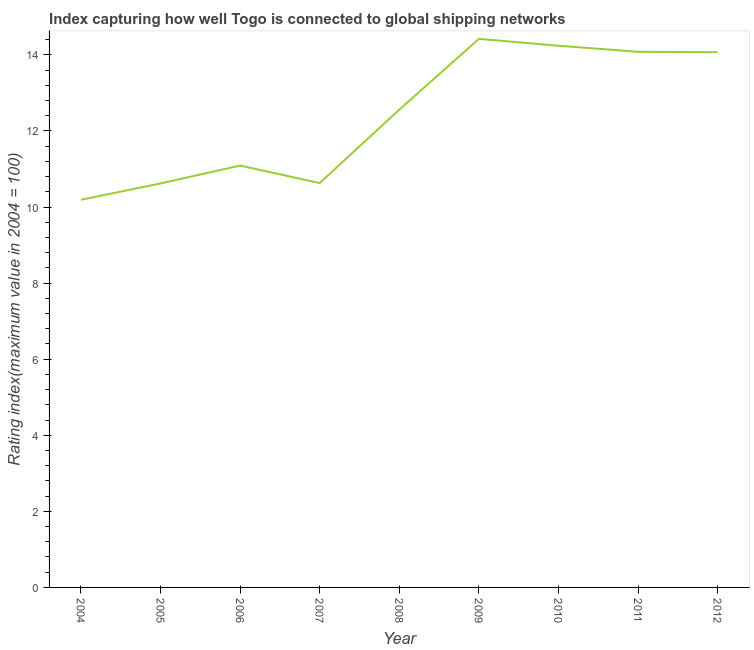What is the liner shipping connectivity index in 2011?
Your response must be concise. 14.08. Across all years, what is the maximum liner shipping connectivity index?
Make the answer very short. 14.42. Across all years, what is the minimum liner shipping connectivity index?
Offer a terse response. 10.19. In which year was the liner shipping connectivity index maximum?
Offer a very short reply. 2009. In which year was the liner shipping connectivity index minimum?
Your answer should be compact. 2004. What is the sum of the liner shipping connectivity index?
Make the answer very short. 111.9. What is the difference between the liner shipping connectivity index in 2004 and 2011?
Your answer should be compact. -3.89. What is the average liner shipping connectivity index per year?
Give a very brief answer. 12.43. What is the median liner shipping connectivity index?
Offer a terse response. 12.56. In how many years, is the liner shipping connectivity index greater than 4 ?
Provide a succinct answer. 9. What is the ratio of the liner shipping connectivity index in 2005 to that in 2011?
Keep it short and to the point. 0.75. Is the difference between the liner shipping connectivity index in 2008 and 2010 greater than the difference between any two years?
Your answer should be compact. No. What is the difference between the highest and the second highest liner shipping connectivity index?
Ensure brevity in your answer.  0.18. What is the difference between the highest and the lowest liner shipping connectivity index?
Provide a succinct answer. 4.23. How many years are there in the graph?
Your answer should be compact. 9. Does the graph contain any zero values?
Keep it short and to the point. No. What is the title of the graph?
Give a very brief answer. Index capturing how well Togo is connected to global shipping networks. What is the label or title of the Y-axis?
Your answer should be very brief. Rating index(maximum value in 2004 = 100). What is the Rating index(maximum value in 2004 = 100) of 2004?
Make the answer very short. 10.19. What is the Rating index(maximum value in 2004 = 100) of 2005?
Provide a short and direct response. 10.62. What is the Rating index(maximum value in 2004 = 100) in 2006?
Ensure brevity in your answer.  11.09. What is the Rating index(maximum value in 2004 = 100) in 2007?
Offer a terse response. 10.63. What is the Rating index(maximum value in 2004 = 100) in 2008?
Your answer should be very brief. 12.56. What is the Rating index(maximum value in 2004 = 100) of 2009?
Ensure brevity in your answer.  14.42. What is the Rating index(maximum value in 2004 = 100) in 2010?
Keep it short and to the point. 14.24. What is the Rating index(maximum value in 2004 = 100) in 2011?
Provide a short and direct response. 14.08. What is the Rating index(maximum value in 2004 = 100) in 2012?
Keep it short and to the point. 14.07. What is the difference between the Rating index(maximum value in 2004 = 100) in 2004 and 2005?
Offer a terse response. -0.43. What is the difference between the Rating index(maximum value in 2004 = 100) in 2004 and 2006?
Make the answer very short. -0.9. What is the difference between the Rating index(maximum value in 2004 = 100) in 2004 and 2007?
Provide a succinct answer. -0.44. What is the difference between the Rating index(maximum value in 2004 = 100) in 2004 and 2008?
Your answer should be compact. -2.37. What is the difference between the Rating index(maximum value in 2004 = 100) in 2004 and 2009?
Keep it short and to the point. -4.23. What is the difference between the Rating index(maximum value in 2004 = 100) in 2004 and 2010?
Offer a very short reply. -4.05. What is the difference between the Rating index(maximum value in 2004 = 100) in 2004 and 2011?
Provide a short and direct response. -3.89. What is the difference between the Rating index(maximum value in 2004 = 100) in 2004 and 2012?
Provide a short and direct response. -3.88. What is the difference between the Rating index(maximum value in 2004 = 100) in 2005 and 2006?
Your response must be concise. -0.47. What is the difference between the Rating index(maximum value in 2004 = 100) in 2005 and 2007?
Provide a short and direct response. -0.01. What is the difference between the Rating index(maximum value in 2004 = 100) in 2005 and 2008?
Ensure brevity in your answer.  -1.94. What is the difference between the Rating index(maximum value in 2004 = 100) in 2005 and 2009?
Your answer should be very brief. -3.8. What is the difference between the Rating index(maximum value in 2004 = 100) in 2005 and 2010?
Your response must be concise. -3.62. What is the difference between the Rating index(maximum value in 2004 = 100) in 2005 and 2011?
Make the answer very short. -3.46. What is the difference between the Rating index(maximum value in 2004 = 100) in 2005 and 2012?
Your answer should be very brief. -3.45. What is the difference between the Rating index(maximum value in 2004 = 100) in 2006 and 2007?
Make the answer very short. 0.46. What is the difference between the Rating index(maximum value in 2004 = 100) in 2006 and 2008?
Keep it short and to the point. -1.47. What is the difference between the Rating index(maximum value in 2004 = 100) in 2006 and 2009?
Offer a terse response. -3.33. What is the difference between the Rating index(maximum value in 2004 = 100) in 2006 and 2010?
Provide a short and direct response. -3.15. What is the difference between the Rating index(maximum value in 2004 = 100) in 2006 and 2011?
Provide a short and direct response. -2.99. What is the difference between the Rating index(maximum value in 2004 = 100) in 2006 and 2012?
Ensure brevity in your answer.  -2.98. What is the difference between the Rating index(maximum value in 2004 = 100) in 2007 and 2008?
Your answer should be compact. -1.93. What is the difference between the Rating index(maximum value in 2004 = 100) in 2007 and 2009?
Your response must be concise. -3.79. What is the difference between the Rating index(maximum value in 2004 = 100) in 2007 and 2010?
Your answer should be very brief. -3.61. What is the difference between the Rating index(maximum value in 2004 = 100) in 2007 and 2011?
Offer a terse response. -3.45. What is the difference between the Rating index(maximum value in 2004 = 100) in 2007 and 2012?
Make the answer very short. -3.44. What is the difference between the Rating index(maximum value in 2004 = 100) in 2008 and 2009?
Make the answer very short. -1.86. What is the difference between the Rating index(maximum value in 2004 = 100) in 2008 and 2010?
Offer a very short reply. -1.68. What is the difference between the Rating index(maximum value in 2004 = 100) in 2008 and 2011?
Your response must be concise. -1.52. What is the difference between the Rating index(maximum value in 2004 = 100) in 2008 and 2012?
Offer a terse response. -1.51. What is the difference between the Rating index(maximum value in 2004 = 100) in 2009 and 2010?
Make the answer very short. 0.18. What is the difference between the Rating index(maximum value in 2004 = 100) in 2009 and 2011?
Your response must be concise. 0.34. What is the difference between the Rating index(maximum value in 2004 = 100) in 2009 and 2012?
Give a very brief answer. 0.35. What is the difference between the Rating index(maximum value in 2004 = 100) in 2010 and 2011?
Keep it short and to the point. 0.16. What is the difference between the Rating index(maximum value in 2004 = 100) in 2010 and 2012?
Make the answer very short. 0.17. What is the difference between the Rating index(maximum value in 2004 = 100) in 2011 and 2012?
Your response must be concise. 0.01. What is the ratio of the Rating index(maximum value in 2004 = 100) in 2004 to that in 2005?
Ensure brevity in your answer.  0.96. What is the ratio of the Rating index(maximum value in 2004 = 100) in 2004 to that in 2006?
Your answer should be compact. 0.92. What is the ratio of the Rating index(maximum value in 2004 = 100) in 2004 to that in 2008?
Give a very brief answer. 0.81. What is the ratio of the Rating index(maximum value in 2004 = 100) in 2004 to that in 2009?
Give a very brief answer. 0.71. What is the ratio of the Rating index(maximum value in 2004 = 100) in 2004 to that in 2010?
Keep it short and to the point. 0.72. What is the ratio of the Rating index(maximum value in 2004 = 100) in 2004 to that in 2011?
Your answer should be very brief. 0.72. What is the ratio of the Rating index(maximum value in 2004 = 100) in 2004 to that in 2012?
Your answer should be compact. 0.72. What is the ratio of the Rating index(maximum value in 2004 = 100) in 2005 to that in 2006?
Offer a very short reply. 0.96. What is the ratio of the Rating index(maximum value in 2004 = 100) in 2005 to that in 2007?
Keep it short and to the point. 1. What is the ratio of the Rating index(maximum value in 2004 = 100) in 2005 to that in 2008?
Provide a short and direct response. 0.85. What is the ratio of the Rating index(maximum value in 2004 = 100) in 2005 to that in 2009?
Your answer should be compact. 0.74. What is the ratio of the Rating index(maximum value in 2004 = 100) in 2005 to that in 2010?
Offer a terse response. 0.75. What is the ratio of the Rating index(maximum value in 2004 = 100) in 2005 to that in 2011?
Your answer should be very brief. 0.75. What is the ratio of the Rating index(maximum value in 2004 = 100) in 2005 to that in 2012?
Provide a short and direct response. 0.76. What is the ratio of the Rating index(maximum value in 2004 = 100) in 2006 to that in 2007?
Ensure brevity in your answer.  1.04. What is the ratio of the Rating index(maximum value in 2004 = 100) in 2006 to that in 2008?
Your answer should be compact. 0.88. What is the ratio of the Rating index(maximum value in 2004 = 100) in 2006 to that in 2009?
Offer a terse response. 0.77. What is the ratio of the Rating index(maximum value in 2004 = 100) in 2006 to that in 2010?
Give a very brief answer. 0.78. What is the ratio of the Rating index(maximum value in 2004 = 100) in 2006 to that in 2011?
Your response must be concise. 0.79. What is the ratio of the Rating index(maximum value in 2004 = 100) in 2006 to that in 2012?
Your answer should be very brief. 0.79. What is the ratio of the Rating index(maximum value in 2004 = 100) in 2007 to that in 2008?
Give a very brief answer. 0.85. What is the ratio of the Rating index(maximum value in 2004 = 100) in 2007 to that in 2009?
Your response must be concise. 0.74. What is the ratio of the Rating index(maximum value in 2004 = 100) in 2007 to that in 2010?
Offer a terse response. 0.75. What is the ratio of the Rating index(maximum value in 2004 = 100) in 2007 to that in 2011?
Keep it short and to the point. 0.76. What is the ratio of the Rating index(maximum value in 2004 = 100) in 2007 to that in 2012?
Keep it short and to the point. 0.76. What is the ratio of the Rating index(maximum value in 2004 = 100) in 2008 to that in 2009?
Offer a terse response. 0.87. What is the ratio of the Rating index(maximum value in 2004 = 100) in 2008 to that in 2010?
Give a very brief answer. 0.88. What is the ratio of the Rating index(maximum value in 2004 = 100) in 2008 to that in 2011?
Give a very brief answer. 0.89. What is the ratio of the Rating index(maximum value in 2004 = 100) in 2008 to that in 2012?
Offer a very short reply. 0.89. What is the ratio of the Rating index(maximum value in 2004 = 100) in 2009 to that in 2011?
Make the answer very short. 1.02. What is the ratio of the Rating index(maximum value in 2004 = 100) in 2010 to that in 2011?
Offer a terse response. 1.01. What is the ratio of the Rating index(maximum value in 2004 = 100) in 2010 to that in 2012?
Your response must be concise. 1.01. What is the ratio of the Rating index(maximum value in 2004 = 100) in 2011 to that in 2012?
Ensure brevity in your answer.  1. 